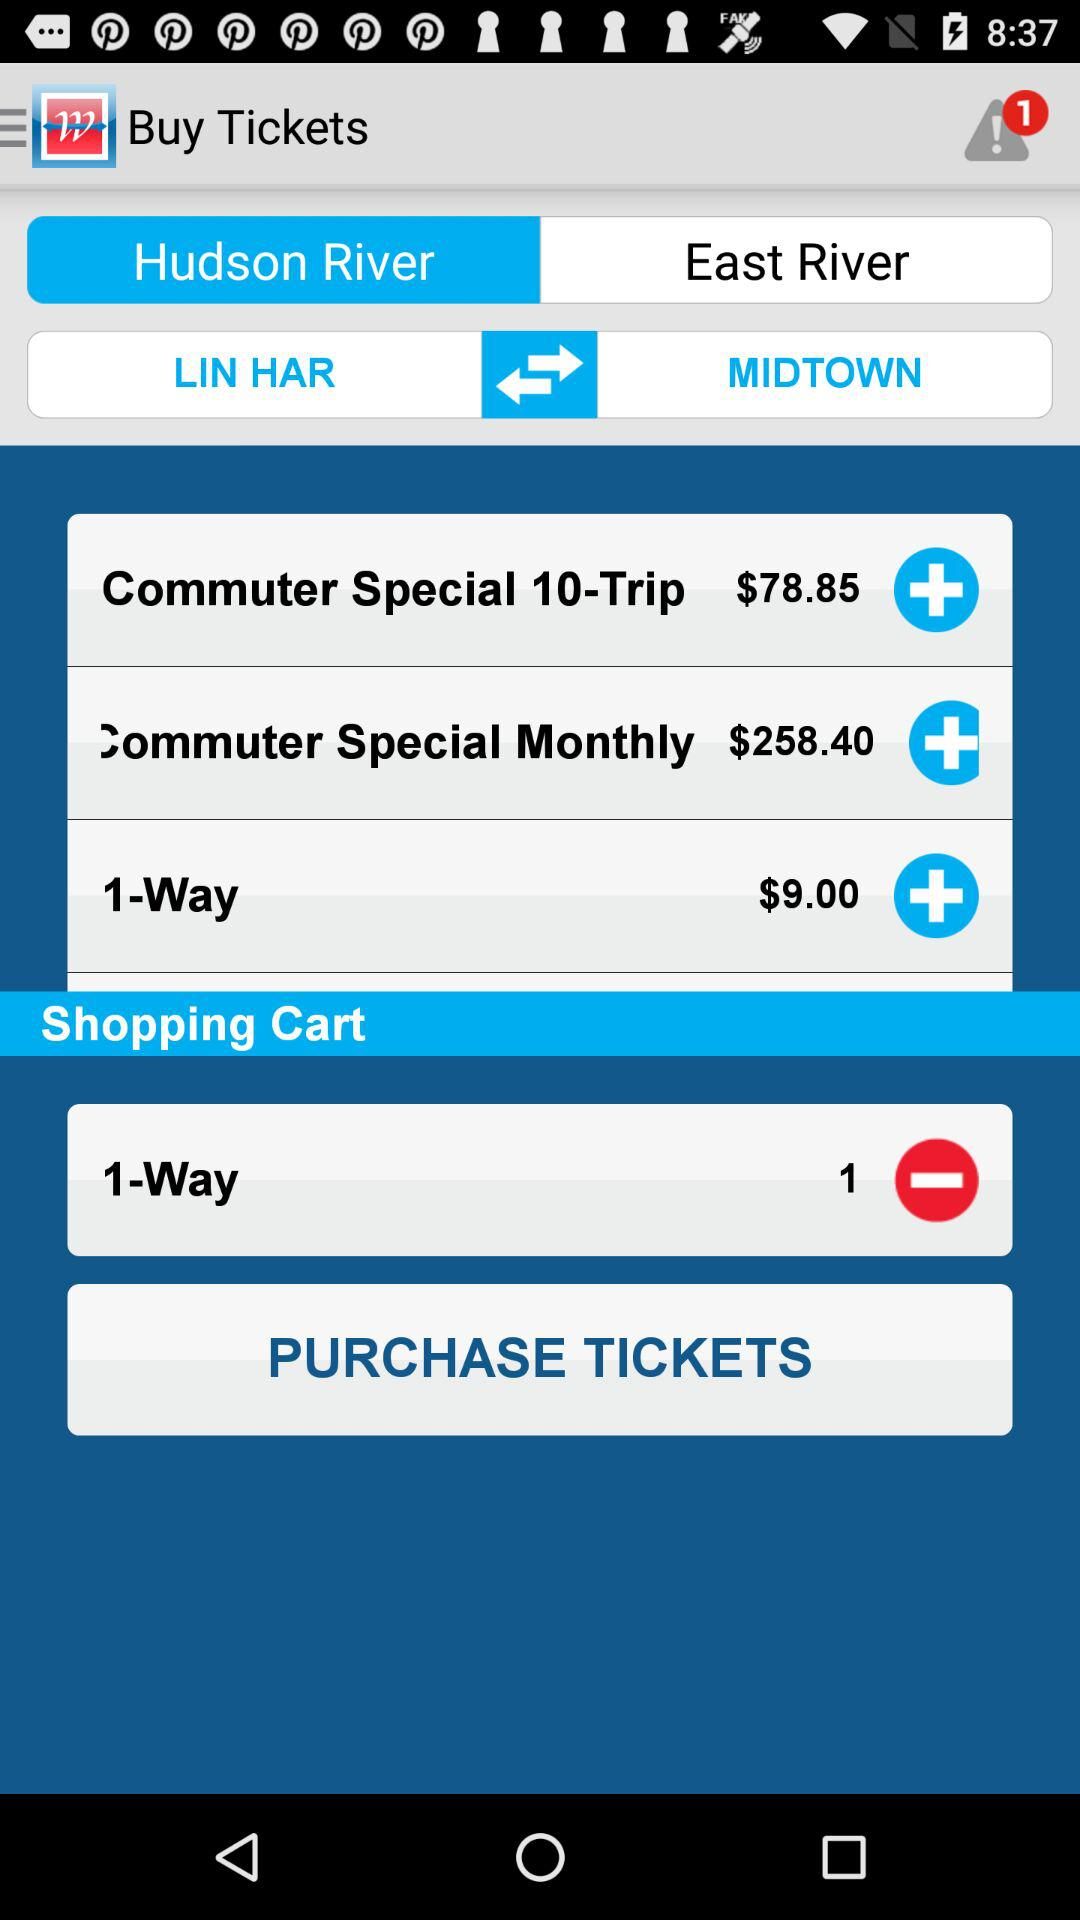What is the fare for the "Commuter Special 10-Trip"? The fare for the "Commuter Special 10-Trip" is $78.85. 